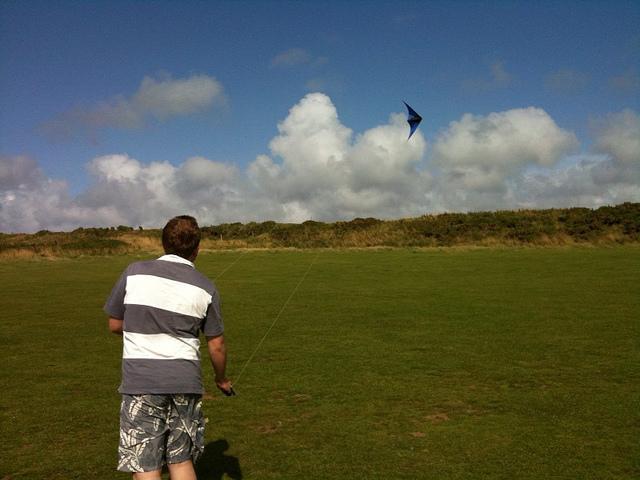How many hands is the man using to control the kite?
Give a very brief answer. 2. How many dogs are there with brown color?
Give a very brief answer. 0. 